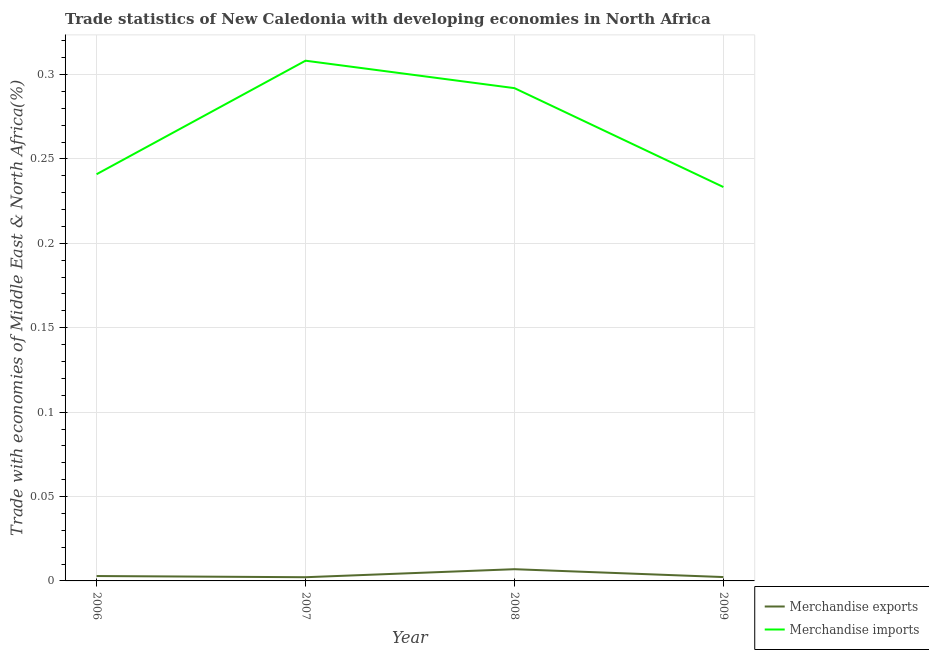How many different coloured lines are there?
Keep it short and to the point. 2. What is the merchandise exports in 2007?
Ensure brevity in your answer.  0. Across all years, what is the maximum merchandise exports?
Make the answer very short. 0.01. Across all years, what is the minimum merchandise exports?
Provide a succinct answer. 0. In which year was the merchandise exports minimum?
Offer a terse response. 2007. What is the total merchandise imports in the graph?
Ensure brevity in your answer.  1.07. What is the difference between the merchandise imports in 2006 and that in 2008?
Offer a very short reply. -0.05. What is the difference between the merchandise imports in 2006 and the merchandise exports in 2009?
Give a very brief answer. 0.24. What is the average merchandise exports per year?
Offer a terse response. 0. In the year 2008, what is the difference between the merchandise exports and merchandise imports?
Provide a succinct answer. -0.28. What is the ratio of the merchandise imports in 2006 to that in 2008?
Provide a succinct answer. 0.83. What is the difference between the highest and the second highest merchandise exports?
Your answer should be compact. 0. What is the difference between the highest and the lowest merchandise exports?
Your answer should be very brief. 0. How many lines are there?
Your answer should be compact. 2. What is the difference between two consecutive major ticks on the Y-axis?
Keep it short and to the point. 0.05. Where does the legend appear in the graph?
Offer a very short reply. Bottom right. How are the legend labels stacked?
Ensure brevity in your answer.  Vertical. What is the title of the graph?
Your response must be concise. Trade statistics of New Caledonia with developing economies in North Africa. Does "Infant" appear as one of the legend labels in the graph?
Ensure brevity in your answer.  No. What is the label or title of the Y-axis?
Make the answer very short. Trade with economies of Middle East & North Africa(%). What is the Trade with economies of Middle East & North Africa(%) in Merchandise exports in 2006?
Your response must be concise. 0. What is the Trade with economies of Middle East & North Africa(%) in Merchandise imports in 2006?
Your answer should be compact. 0.24. What is the Trade with economies of Middle East & North Africa(%) in Merchandise exports in 2007?
Offer a terse response. 0. What is the Trade with economies of Middle East & North Africa(%) in Merchandise imports in 2007?
Your answer should be compact. 0.31. What is the Trade with economies of Middle East & North Africa(%) of Merchandise exports in 2008?
Your answer should be compact. 0.01. What is the Trade with economies of Middle East & North Africa(%) of Merchandise imports in 2008?
Make the answer very short. 0.29. What is the Trade with economies of Middle East & North Africa(%) of Merchandise exports in 2009?
Provide a succinct answer. 0. What is the Trade with economies of Middle East & North Africa(%) of Merchandise imports in 2009?
Make the answer very short. 0.23. Across all years, what is the maximum Trade with economies of Middle East & North Africa(%) of Merchandise exports?
Your response must be concise. 0.01. Across all years, what is the maximum Trade with economies of Middle East & North Africa(%) of Merchandise imports?
Make the answer very short. 0.31. Across all years, what is the minimum Trade with economies of Middle East & North Africa(%) in Merchandise exports?
Keep it short and to the point. 0. Across all years, what is the minimum Trade with economies of Middle East & North Africa(%) of Merchandise imports?
Provide a succinct answer. 0.23. What is the total Trade with economies of Middle East & North Africa(%) in Merchandise exports in the graph?
Provide a short and direct response. 0.01. What is the total Trade with economies of Middle East & North Africa(%) of Merchandise imports in the graph?
Your answer should be very brief. 1.07. What is the difference between the Trade with economies of Middle East & North Africa(%) in Merchandise exports in 2006 and that in 2007?
Keep it short and to the point. 0. What is the difference between the Trade with economies of Middle East & North Africa(%) of Merchandise imports in 2006 and that in 2007?
Ensure brevity in your answer.  -0.07. What is the difference between the Trade with economies of Middle East & North Africa(%) in Merchandise exports in 2006 and that in 2008?
Keep it short and to the point. -0. What is the difference between the Trade with economies of Middle East & North Africa(%) of Merchandise imports in 2006 and that in 2008?
Ensure brevity in your answer.  -0.05. What is the difference between the Trade with economies of Middle East & North Africa(%) in Merchandise exports in 2006 and that in 2009?
Make the answer very short. 0. What is the difference between the Trade with economies of Middle East & North Africa(%) of Merchandise imports in 2006 and that in 2009?
Give a very brief answer. 0.01. What is the difference between the Trade with economies of Middle East & North Africa(%) of Merchandise exports in 2007 and that in 2008?
Provide a short and direct response. -0. What is the difference between the Trade with economies of Middle East & North Africa(%) in Merchandise imports in 2007 and that in 2008?
Make the answer very short. 0.02. What is the difference between the Trade with economies of Middle East & North Africa(%) of Merchandise exports in 2007 and that in 2009?
Your answer should be very brief. -0. What is the difference between the Trade with economies of Middle East & North Africa(%) of Merchandise imports in 2007 and that in 2009?
Ensure brevity in your answer.  0.07. What is the difference between the Trade with economies of Middle East & North Africa(%) of Merchandise exports in 2008 and that in 2009?
Your response must be concise. 0. What is the difference between the Trade with economies of Middle East & North Africa(%) of Merchandise imports in 2008 and that in 2009?
Your answer should be very brief. 0.06. What is the difference between the Trade with economies of Middle East & North Africa(%) in Merchandise exports in 2006 and the Trade with economies of Middle East & North Africa(%) in Merchandise imports in 2007?
Make the answer very short. -0.31. What is the difference between the Trade with economies of Middle East & North Africa(%) of Merchandise exports in 2006 and the Trade with economies of Middle East & North Africa(%) of Merchandise imports in 2008?
Your answer should be very brief. -0.29. What is the difference between the Trade with economies of Middle East & North Africa(%) of Merchandise exports in 2006 and the Trade with economies of Middle East & North Africa(%) of Merchandise imports in 2009?
Your response must be concise. -0.23. What is the difference between the Trade with economies of Middle East & North Africa(%) of Merchandise exports in 2007 and the Trade with economies of Middle East & North Africa(%) of Merchandise imports in 2008?
Make the answer very short. -0.29. What is the difference between the Trade with economies of Middle East & North Africa(%) in Merchandise exports in 2007 and the Trade with economies of Middle East & North Africa(%) in Merchandise imports in 2009?
Your response must be concise. -0.23. What is the difference between the Trade with economies of Middle East & North Africa(%) in Merchandise exports in 2008 and the Trade with economies of Middle East & North Africa(%) in Merchandise imports in 2009?
Give a very brief answer. -0.23. What is the average Trade with economies of Middle East & North Africa(%) of Merchandise exports per year?
Ensure brevity in your answer.  0. What is the average Trade with economies of Middle East & North Africa(%) of Merchandise imports per year?
Keep it short and to the point. 0.27. In the year 2006, what is the difference between the Trade with economies of Middle East & North Africa(%) of Merchandise exports and Trade with economies of Middle East & North Africa(%) of Merchandise imports?
Keep it short and to the point. -0.24. In the year 2007, what is the difference between the Trade with economies of Middle East & North Africa(%) of Merchandise exports and Trade with economies of Middle East & North Africa(%) of Merchandise imports?
Your answer should be very brief. -0.31. In the year 2008, what is the difference between the Trade with economies of Middle East & North Africa(%) in Merchandise exports and Trade with economies of Middle East & North Africa(%) in Merchandise imports?
Keep it short and to the point. -0.28. In the year 2009, what is the difference between the Trade with economies of Middle East & North Africa(%) of Merchandise exports and Trade with economies of Middle East & North Africa(%) of Merchandise imports?
Your answer should be compact. -0.23. What is the ratio of the Trade with economies of Middle East & North Africa(%) in Merchandise exports in 2006 to that in 2007?
Provide a succinct answer. 1.32. What is the ratio of the Trade with economies of Middle East & North Africa(%) of Merchandise imports in 2006 to that in 2007?
Keep it short and to the point. 0.78. What is the ratio of the Trade with economies of Middle East & North Africa(%) in Merchandise exports in 2006 to that in 2008?
Provide a succinct answer. 0.42. What is the ratio of the Trade with economies of Middle East & North Africa(%) in Merchandise imports in 2006 to that in 2008?
Your response must be concise. 0.83. What is the ratio of the Trade with economies of Middle East & North Africa(%) of Merchandise exports in 2006 to that in 2009?
Offer a terse response. 1.27. What is the ratio of the Trade with economies of Middle East & North Africa(%) in Merchandise imports in 2006 to that in 2009?
Ensure brevity in your answer.  1.03. What is the ratio of the Trade with economies of Middle East & North Africa(%) of Merchandise exports in 2007 to that in 2008?
Make the answer very short. 0.32. What is the ratio of the Trade with economies of Middle East & North Africa(%) of Merchandise imports in 2007 to that in 2008?
Offer a terse response. 1.06. What is the ratio of the Trade with economies of Middle East & North Africa(%) in Merchandise exports in 2007 to that in 2009?
Provide a succinct answer. 0.96. What is the ratio of the Trade with economies of Middle East & North Africa(%) in Merchandise imports in 2007 to that in 2009?
Provide a short and direct response. 1.32. What is the ratio of the Trade with economies of Middle East & North Africa(%) in Merchandise exports in 2008 to that in 2009?
Provide a succinct answer. 3.03. What is the ratio of the Trade with economies of Middle East & North Africa(%) of Merchandise imports in 2008 to that in 2009?
Offer a very short reply. 1.25. What is the difference between the highest and the second highest Trade with economies of Middle East & North Africa(%) in Merchandise exports?
Offer a terse response. 0. What is the difference between the highest and the second highest Trade with economies of Middle East & North Africa(%) in Merchandise imports?
Offer a very short reply. 0.02. What is the difference between the highest and the lowest Trade with economies of Middle East & North Africa(%) of Merchandise exports?
Offer a terse response. 0. What is the difference between the highest and the lowest Trade with economies of Middle East & North Africa(%) of Merchandise imports?
Ensure brevity in your answer.  0.07. 